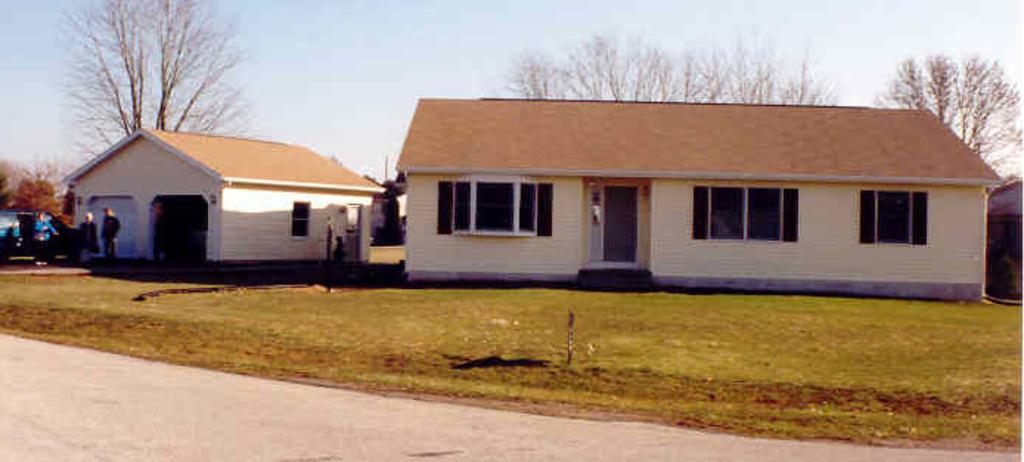What type of structures are present in the image? The image contains houses. What can be seen at the bottom of the image? There is green grass and a road at the bottom of the image. What is happening to the left of the image? There are three persons standing beside a vehicle. Can you describe the vehicle in the image? The vehicle is visible in the image. What is visible in the background of the image? There are trees in the background of the image. What taste does the grass have in the image? The image does not provide information about the taste of the grass. What rule is being enforced by the trees in the background? There is no indication of any rule being enforced by the trees in the background; they are simply part of the natural scenery. 